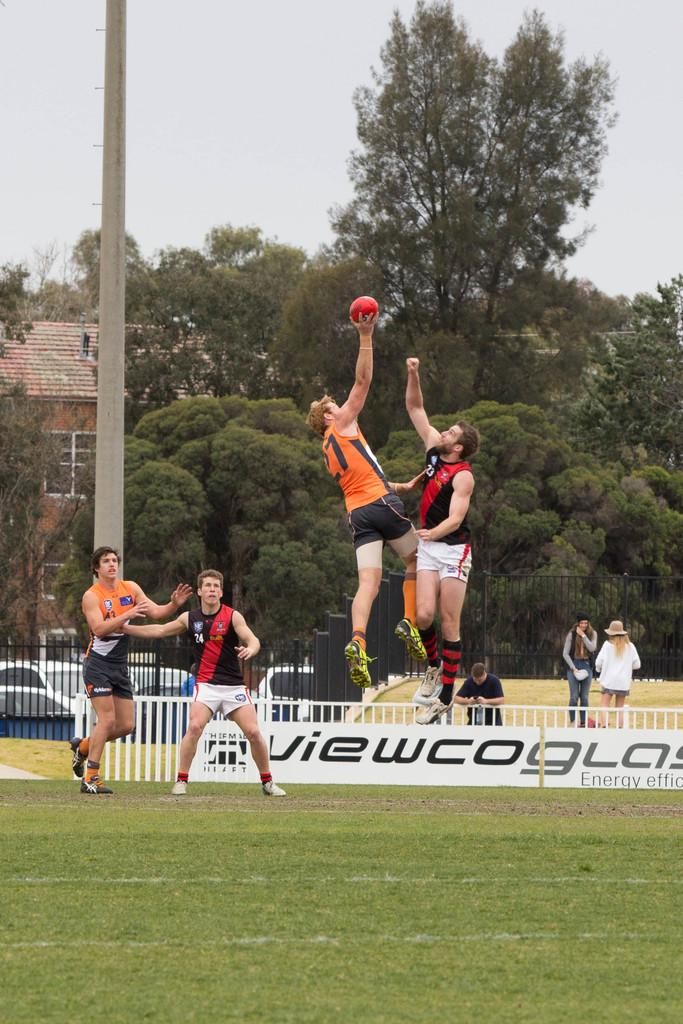<image>
Describe the image concisely. On an athletic field, players compete in front of an ad reading "Energy Efficient". 